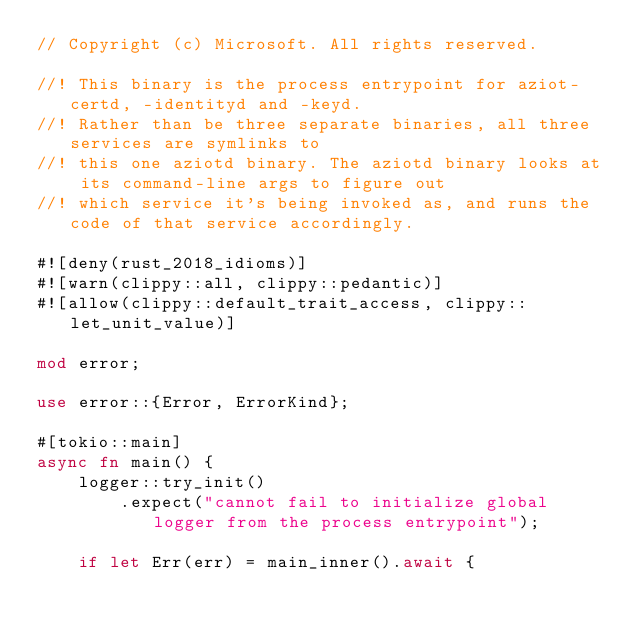<code> <loc_0><loc_0><loc_500><loc_500><_Rust_>// Copyright (c) Microsoft. All rights reserved.

//! This binary is the process entrypoint for aziot-certd, -identityd and -keyd.
//! Rather than be three separate binaries, all three services are symlinks to
//! this one aziotd binary. The aziotd binary looks at its command-line args to figure out
//! which service it's being invoked as, and runs the code of that service accordingly.

#![deny(rust_2018_idioms)]
#![warn(clippy::all, clippy::pedantic)]
#![allow(clippy::default_trait_access, clippy::let_unit_value)]

mod error;

use error::{Error, ErrorKind};

#[tokio::main]
async fn main() {
    logger::try_init()
        .expect("cannot fail to initialize global logger from the process entrypoint");

    if let Err(err) = main_inner().await {</code> 